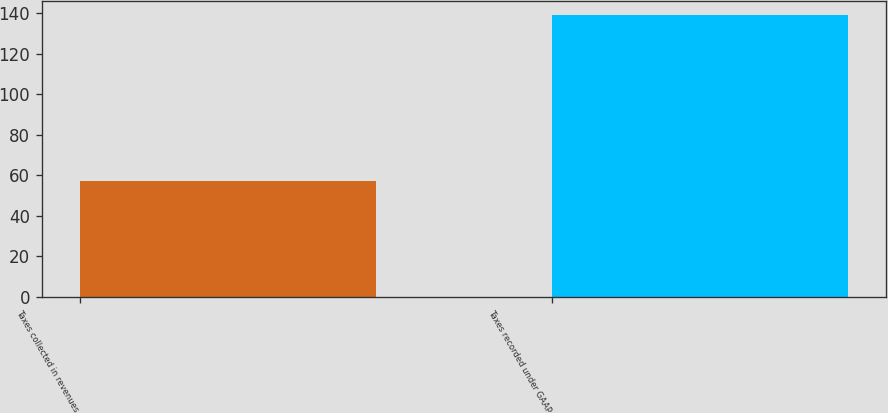<chart> <loc_0><loc_0><loc_500><loc_500><bar_chart><fcel>Taxes collected in revenues<fcel>Taxes recorded under GAAP<nl><fcel>57<fcel>139<nl></chart> 